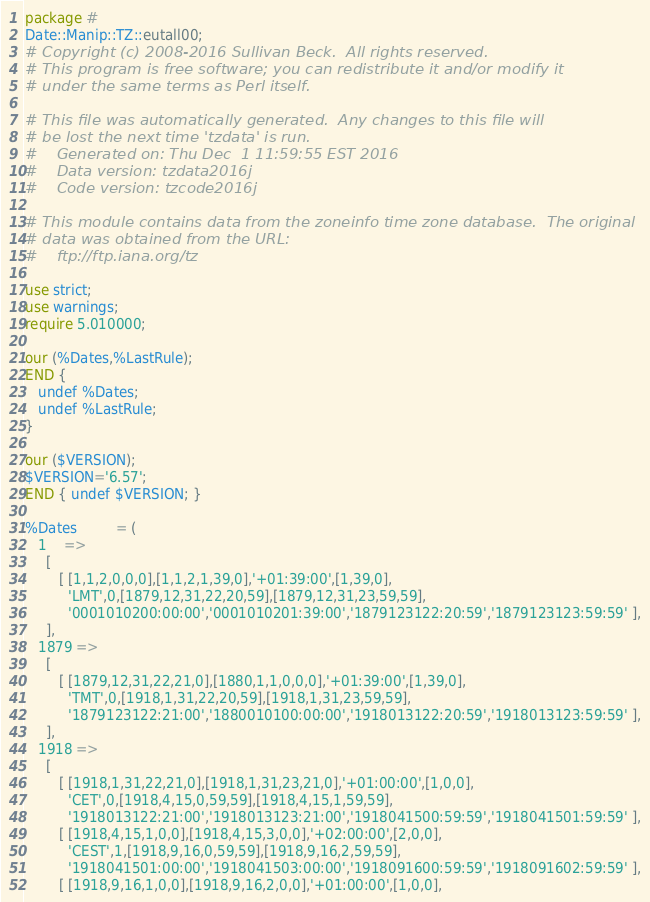Convert code to text. <code><loc_0><loc_0><loc_500><loc_500><_Perl_>package #
Date::Manip::TZ::eutall00;
# Copyright (c) 2008-2016 Sullivan Beck.  All rights reserved.
# This program is free software; you can redistribute it and/or modify it
# under the same terms as Perl itself.

# This file was automatically generated.  Any changes to this file will
# be lost the next time 'tzdata' is run.
#    Generated on: Thu Dec  1 11:59:55 EST 2016
#    Data version: tzdata2016j
#    Code version: tzcode2016j

# This module contains data from the zoneinfo time zone database.  The original
# data was obtained from the URL:
#    ftp://ftp.iana.org/tz

use strict;
use warnings;
require 5.010000;

our (%Dates,%LastRule);
END {
   undef %Dates;
   undef %LastRule;
}

our ($VERSION);
$VERSION='6.57';
END { undef $VERSION; }

%Dates         = (
   1    =>
     [
        [ [1,1,2,0,0,0],[1,1,2,1,39,0],'+01:39:00',[1,39,0],
          'LMT',0,[1879,12,31,22,20,59],[1879,12,31,23,59,59],
          '0001010200:00:00','0001010201:39:00','1879123122:20:59','1879123123:59:59' ],
     ],
   1879 =>
     [
        [ [1879,12,31,22,21,0],[1880,1,1,0,0,0],'+01:39:00',[1,39,0],
          'TMT',0,[1918,1,31,22,20,59],[1918,1,31,23,59,59],
          '1879123122:21:00','1880010100:00:00','1918013122:20:59','1918013123:59:59' ],
     ],
   1918 =>
     [
        [ [1918,1,31,22,21,0],[1918,1,31,23,21,0],'+01:00:00',[1,0,0],
          'CET',0,[1918,4,15,0,59,59],[1918,4,15,1,59,59],
          '1918013122:21:00','1918013123:21:00','1918041500:59:59','1918041501:59:59' ],
        [ [1918,4,15,1,0,0],[1918,4,15,3,0,0],'+02:00:00',[2,0,0],
          'CEST',1,[1918,9,16,0,59,59],[1918,9,16,2,59,59],
          '1918041501:00:00','1918041503:00:00','1918091600:59:59','1918091602:59:59' ],
        [ [1918,9,16,1,0,0],[1918,9,16,2,0,0],'+01:00:00',[1,0,0],</code> 